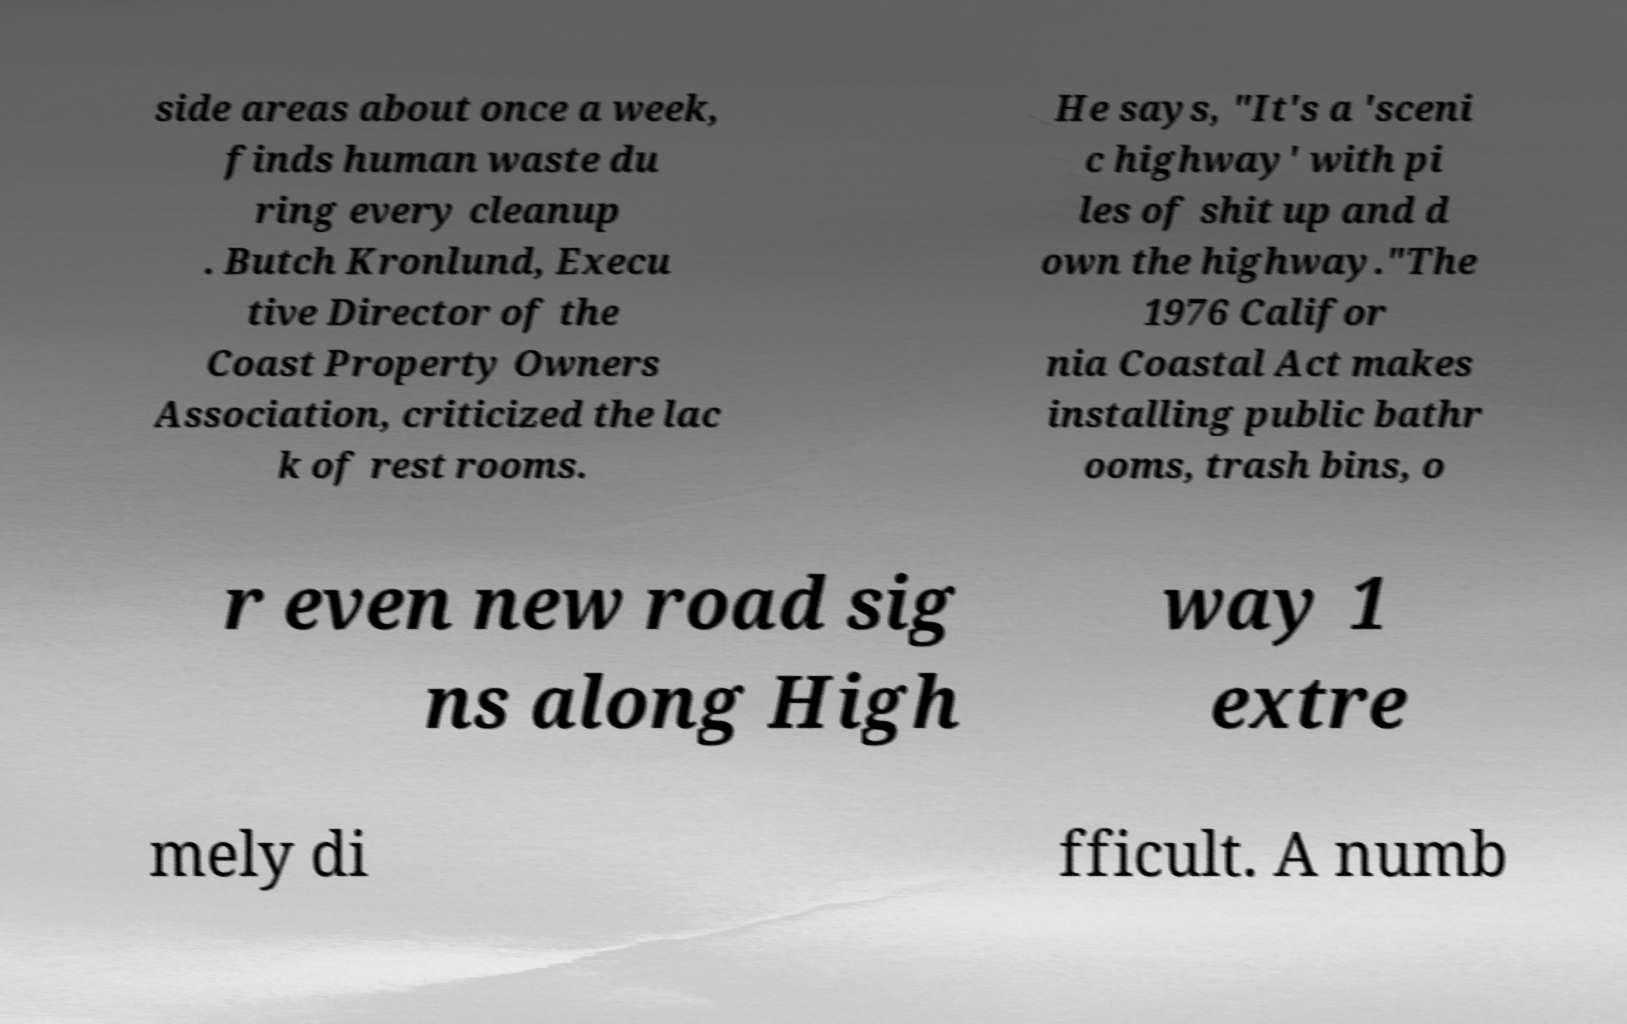Could you extract and type out the text from this image? side areas about once a week, finds human waste du ring every cleanup . Butch Kronlund, Execu tive Director of the Coast Property Owners Association, criticized the lac k of rest rooms. He says, "It's a 'sceni c highway' with pi les of shit up and d own the highway."The 1976 Califor nia Coastal Act makes installing public bathr ooms, trash bins, o r even new road sig ns along High way 1 extre mely di fficult. A numb 